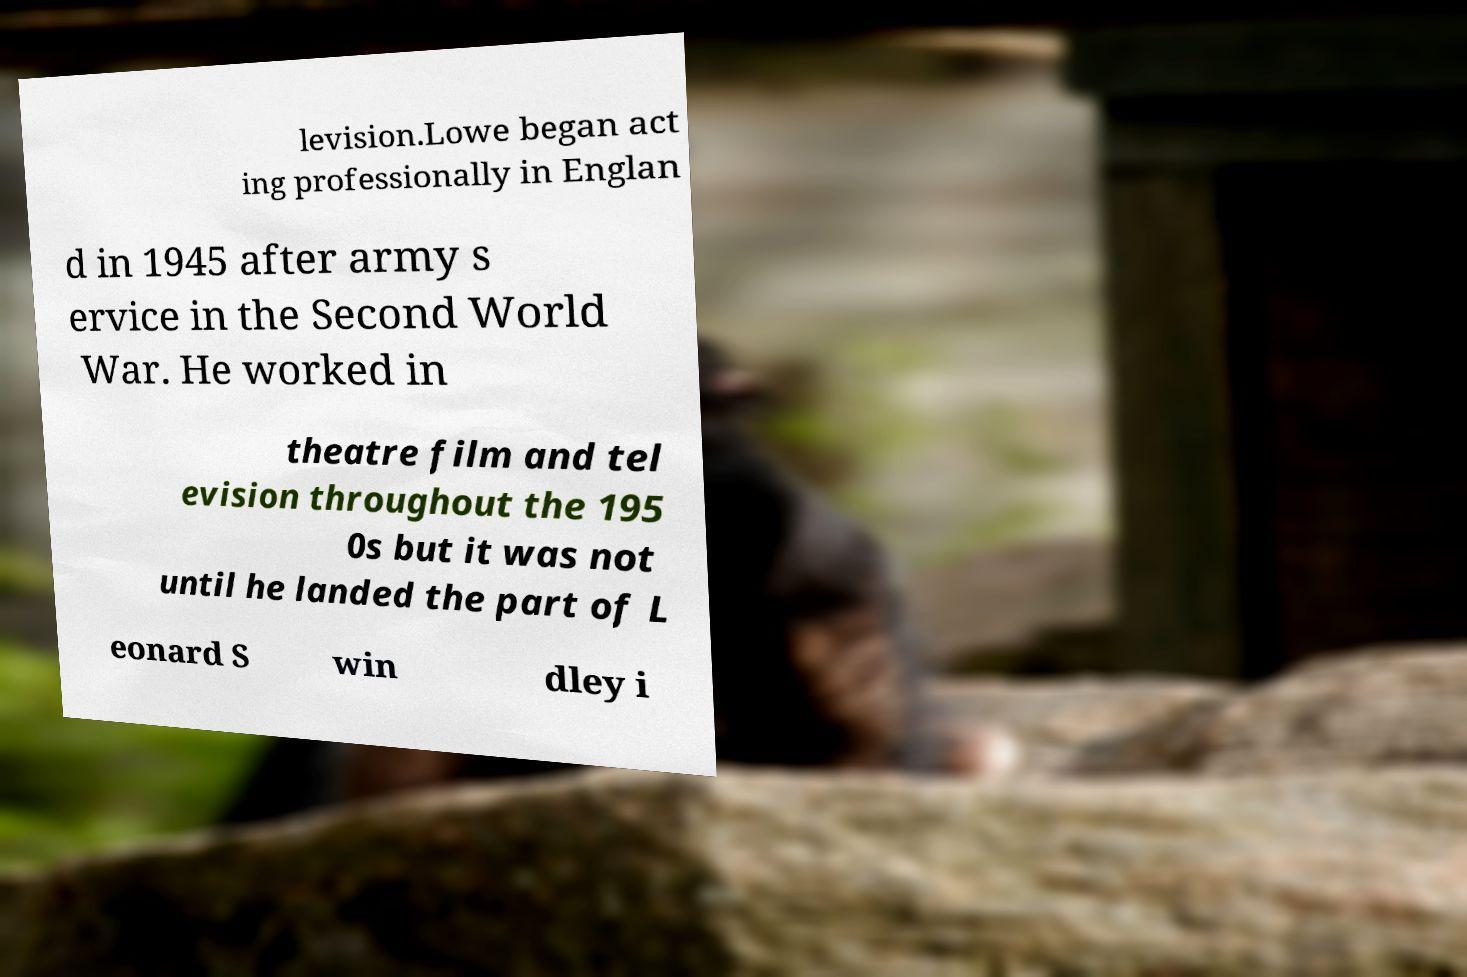Please read and relay the text visible in this image. What does it say? levision.Lowe began act ing professionally in Englan d in 1945 after army s ervice in the Second World War. He worked in theatre film and tel evision throughout the 195 0s but it was not until he landed the part of L eonard S win dley i 